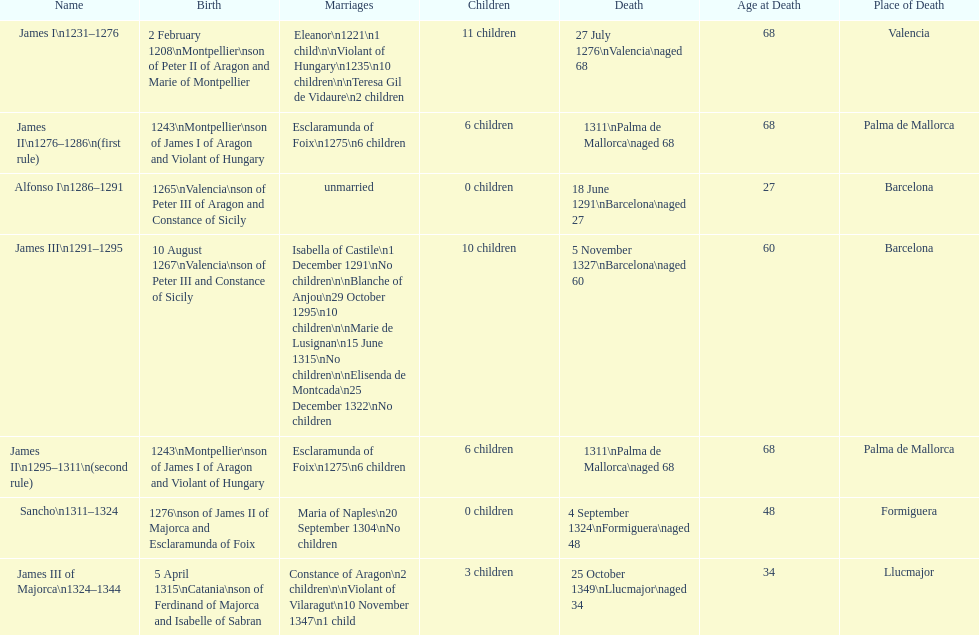How many total marriages did james i have? 3. 